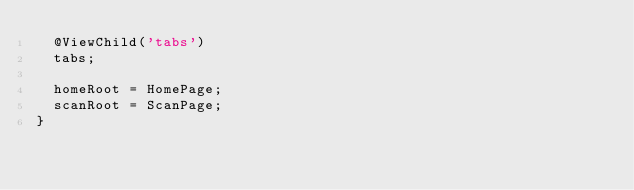<code> <loc_0><loc_0><loc_500><loc_500><_TypeScript_>  @ViewChild('tabs')
  tabs;

  homeRoot = HomePage;
  scanRoot = ScanPage;
}
</code> 